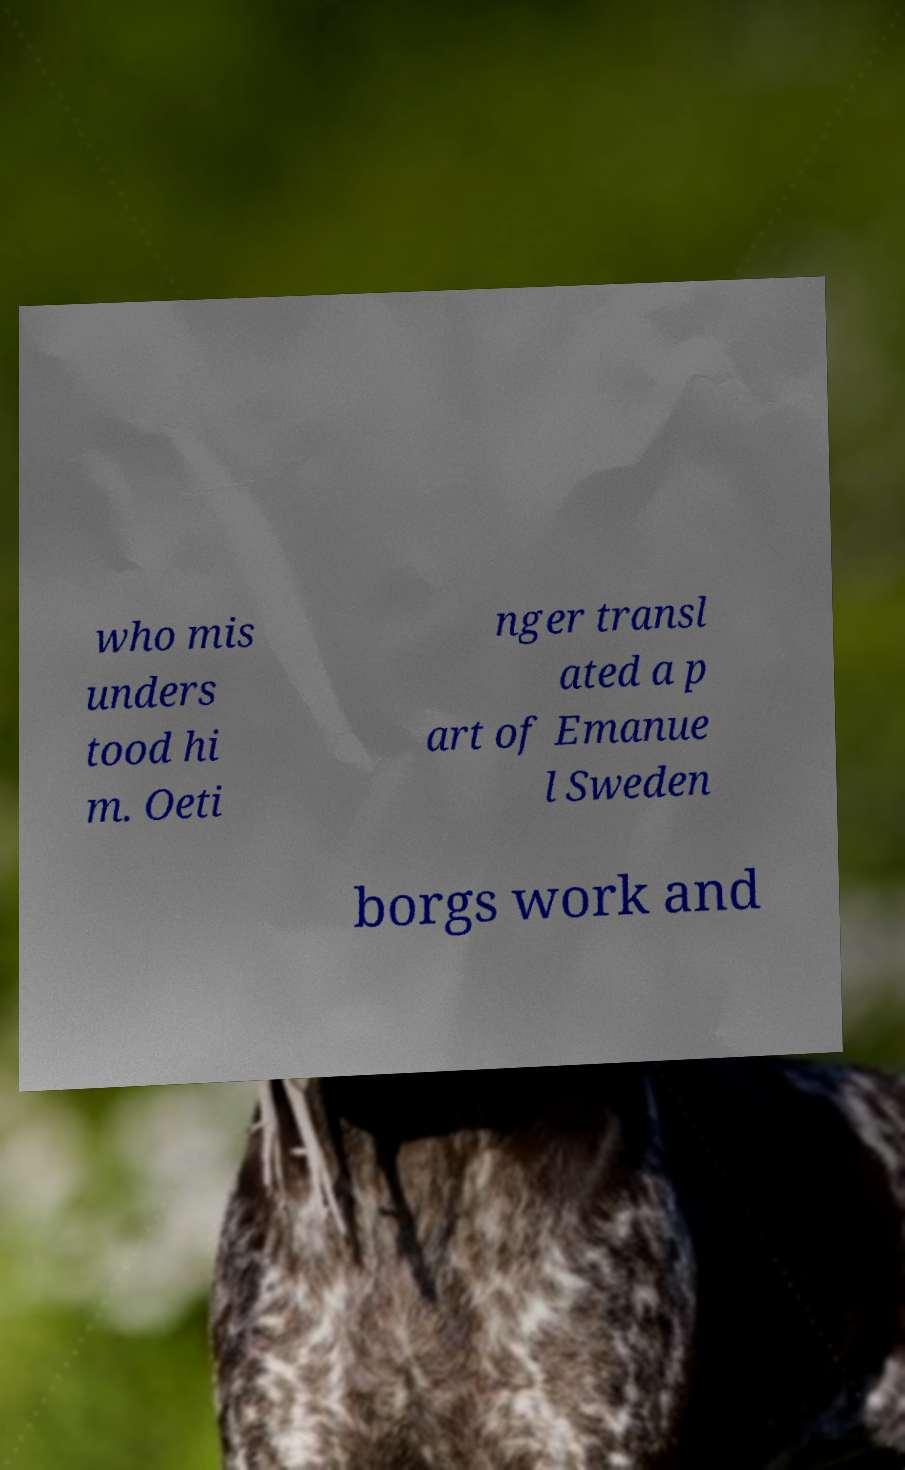There's text embedded in this image that I need extracted. Can you transcribe it verbatim? who mis unders tood hi m. Oeti nger transl ated a p art of Emanue l Sweden borgs work and 